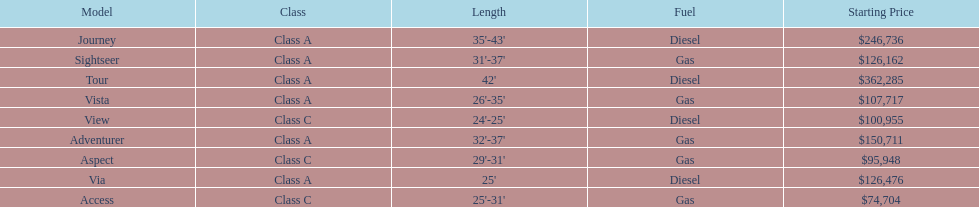Which model had the highest starting price Tour. 